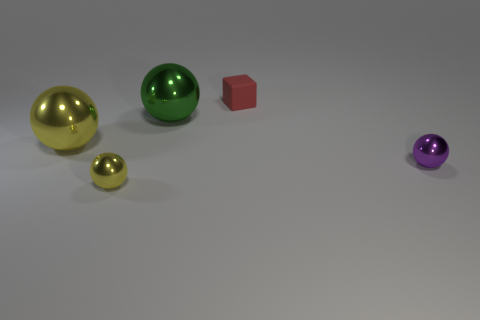What size is the yellow shiny thing that is in front of the metallic object that is to the right of the small red rubber block on the right side of the large green thing?
Keep it short and to the point. Small. Do the sphere to the right of the small block and the tiny block have the same material?
Offer a terse response. No. Is the number of tiny yellow spheres behind the rubber block the same as the number of objects left of the green metal sphere?
Your response must be concise. No. Is there any other thing that is the same size as the red matte cube?
Provide a succinct answer. Yes. There is a purple thing that is the same shape as the green thing; what is its material?
Your answer should be very brief. Metal. There is a small object right of the small object that is behind the large yellow sphere; are there any purple shiny objects that are on the right side of it?
Your response must be concise. No. There is a big metal thing that is on the right side of the big yellow metallic thing; does it have the same shape as the tiny shiny thing in front of the small purple metal sphere?
Your answer should be very brief. Yes. Are there more small purple objects on the left side of the red object than purple metal objects?
Offer a terse response. No. What number of objects are either small rubber cubes or tiny gray matte things?
Your answer should be compact. 1. What is the color of the block?
Your response must be concise. Red. 